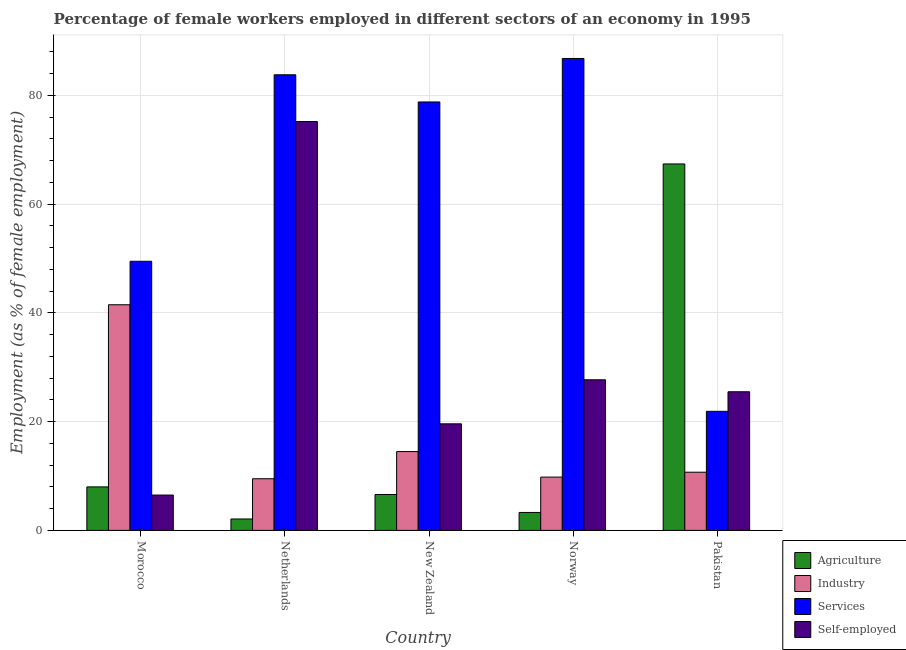How many groups of bars are there?
Offer a very short reply. 5. Are the number of bars per tick equal to the number of legend labels?
Your answer should be compact. Yes. Are the number of bars on each tick of the X-axis equal?
Your answer should be compact. Yes. How many bars are there on the 5th tick from the right?
Ensure brevity in your answer.  4. What is the label of the 2nd group of bars from the left?
Make the answer very short. Netherlands. What is the percentage of female workers in services in Norway?
Your answer should be compact. 86.8. Across all countries, what is the maximum percentage of female workers in services?
Your answer should be compact. 86.8. Across all countries, what is the minimum percentage of self employed female workers?
Give a very brief answer. 6.5. In which country was the percentage of self employed female workers minimum?
Your response must be concise. Morocco. What is the total percentage of female workers in industry in the graph?
Provide a short and direct response. 86. What is the difference between the percentage of female workers in industry in Morocco and that in New Zealand?
Offer a terse response. 27. What is the difference between the percentage of self employed female workers in Netherlands and the percentage of female workers in industry in Pakistan?
Offer a very short reply. 64.5. What is the average percentage of self employed female workers per country?
Your answer should be compact. 30.9. What is the difference between the percentage of female workers in agriculture and percentage of self employed female workers in New Zealand?
Your answer should be very brief. -13. In how many countries, is the percentage of self employed female workers greater than 60 %?
Make the answer very short. 1. What is the ratio of the percentage of female workers in services in Norway to that in Pakistan?
Your response must be concise. 3.96. What is the difference between the highest and the second highest percentage of female workers in services?
Provide a short and direct response. 3. What is the difference between the highest and the lowest percentage of self employed female workers?
Offer a terse response. 68.7. Is it the case that in every country, the sum of the percentage of female workers in services and percentage of self employed female workers is greater than the sum of percentage of female workers in agriculture and percentage of female workers in industry?
Ensure brevity in your answer.  Yes. What does the 2nd bar from the left in New Zealand represents?
Give a very brief answer. Industry. What does the 4th bar from the right in Morocco represents?
Provide a succinct answer. Agriculture. Are all the bars in the graph horizontal?
Provide a short and direct response. No. What is the difference between two consecutive major ticks on the Y-axis?
Your answer should be very brief. 20. Does the graph contain grids?
Make the answer very short. Yes. Where does the legend appear in the graph?
Your answer should be compact. Bottom right. How many legend labels are there?
Provide a succinct answer. 4. What is the title of the graph?
Offer a terse response. Percentage of female workers employed in different sectors of an economy in 1995. What is the label or title of the Y-axis?
Offer a terse response. Employment (as % of female employment). What is the Employment (as % of female employment) in Agriculture in Morocco?
Your answer should be compact. 8. What is the Employment (as % of female employment) of Industry in Morocco?
Provide a short and direct response. 41.5. What is the Employment (as % of female employment) in Services in Morocco?
Your answer should be very brief. 49.5. What is the Employment (as % of female employment) of Agriculture in Netherlands?
Give a very brief answer. 2.1. What is the Employment (as % of female employment) of Industry in Netherlands?
Offer a very short reply. 9.5. What is the Employment (as % of female employment) in Services in Netherlands?
Your answer should be compact. 83.8. What is the Employment (as % of female employment) in Self-employed in Netherlands?
Your response must be concise. 75.2. What is the Employment (as % of female employment) in Agriculture in New Zealand?
Offer a terse response. 6.6. What is the Employment (as % of female employment) of Industry in New Zealand?
Offer a very short reply. 14.5. What is the Employment (as % of female employment) of Services in New Zealand?
Ensure brevity in your answer.  78.8. What is the Employment (as % of female employment) of Self-employed in New Zealand?
Give a very brief answer. 19.6. What is the Employment (as % of female employment) in Agriculture in Norway?
Offer a very short reply. 3.3. What is the Employment (as % of female employment) of Industry in Norway?
Your answer should be very brief. 9.8. What is the Employment (as % of female employment) of Services in Norway?
Your answer should be compact. 86.8. What is the Employment (as % of female employment) in Self-employed in Norway?
Give a very brief answer. 27.7. What is the Employment (as % of female employment) of Agriculture in Pakistan?
Ensure brevity in your answer.  67.4. What is the Employment (as % of female employment) of Industry in Pakistan?
Keep it short and to the point. 10.7. What is the Employment (as % of female employment) in Services in Pakistan?
Keep it short and to the point. 21.9. Across all countries, what is the maximum Employment (as % of female employment) in Agriculture?
Your answer should be very brief. 67.4. Across all countries, what is the maximum Employment (as % of female employment) in Industry?
Your response must be concise. 41.5. Across all countries, what is the maximum Employment (as % of female employment) of Services?
Offer a very short reply. 86.8. Across all countries, what is the maximum Employment (as % of female employment) of Self-employed?
Offer a very short reply. 75.2. Across all countries, what is the minimum Employment (as % of female employment) in Agriculture?
Keep it short and to the point. 2.1. Across all countries, what is the minimum Employment (as % of female employment) in Services?
Your answer should be very brief. 21.9. What is the total Employment (as % of female employment) of Agriculture in the graph?
Make the answer very short. 87.4. What is the total Employment (as % of female employment) in Industry in the graph?
Make the answer very short. 86. What is the total Employment (as % of female employment) in Services in the graph?
Your answer should be compact. 320.8. What is the total Employment (as % of female employment) of Self-employed in the graph?
Give a very brief answer. 154.5. What is the difference between the Employment (as % of female employment) of Industry in Morocco and that in Netherlands?
Keep it short and to the point. 32. What is the difference between the Employment (as % of female employment) in Services in Morocco and that in Netherlands?
Ensure brevity in your answer.  -34.3. What is the difference between the Employment (as % of female employment) in Self-employed in Morocco and that in Netherlands?
Ensure brevity in your answer.  -68.7. What is the difference between the Employment (as % of female employment) of Industry in Morocco and that in New Zealand?
Keep it short and to the point. 27. What is the difference between the Employment (as % of female employment) in Services in Morocco and that in New Zealand?
Provide a succinct answer. -29.3. What is the difference between the Employment (as % of female employment) of Industry in Morocco and that in Norway?
Keep it short and to the point. 31.7. What is the difference between the Employment (as % of female employment) of Services in Morocco and that in Norway?
Provide a succinct answer. -37.3. What is the difference between the Employment (as % of female employment) of Self-employed in Morocco and that in Norway?
Offer a terse response. -21.2. What is the difference between the Employment (as % of female employment) in Agriculture in Morocco and that in Pakistan?
Your response must be concise. -59.4. What is the difference between the Employment (as % of female employment) in Industry in Morocco and that in Pakistan?
Your answer should be compact. 30.8. What is the difference between the Employment (as % of female employment) in Services in Morocco and that in Pakistan?
Ensure brevity in your answer.  27.6. What is the difference between the Employment (as % of female employment) of Agriculture in Netherlands and that in New Zealand?
Provide a succinct answer. -4.5. What is the difference between the Employment (as % of female employment) in Services in Netherlands and that in New Zealand?
Offer a terse response. 5. What is the difference between the Employment (as % of female employment) in Self-employed in Netherlands and that in New Zealand?
Offer a terse response. 55.6. What is the difference between the Employment (as % of female employment) of Agriculture in Netherlands and that in Norway?
Make the answer very short. -1.2. What is the difference between the Employment (as % of female employment) in Self-employed in Netherlands and that in Norway?
Give a very brief answer. 47.5. What is the difference between the Employment (as % of female employment) of Agriculture in Netherlands and that in Pakistan?
Keep it short and to the point. -65.3. What is the difference between the Employment (as % of female employment) of Services in Netherlands and that in Pakistan?
Provide a short and direct response. 61.9. What is the difference between the Employment (as % of female employment) in Self-employed in Netherlands and that in Pakistan?
Offer a very short reply. 49.7. What is the difference between the Employment (as % of female employment) of Agriculture in New Zealand and that in Norway?
Your response must be concise. 3.3. What is the difference between the Employment (as % of female employment) in Industry in New Zealand and that in Norway?
Provide a succinct answer. 4.7. What is the difference between the Employment (as % of female employment) of Services in New Zealand and that in Norway?
Your response must be concise. -8. What is the difference between the Employment (as % of female employment) of Self-employed in New Zealand and that in Norway?
Your answer should be compact. -8.1. What is the difference between the Employment (as % of female employment) in Agriculture in New Zealand and that in Pakistan?
Provide a short and direct response. -60.8. What is the difference between the Employment (as % of female employment) of Services in New Zealand and that in Pakistan?
Keep it short and to the point. 56.9. What is the difference between the Employment (as % of female employment) in Agriculture in Norway and that in Pakistan?
Offer a very short reply. -64.1. What is the difference between the Employment (as % of female employment) in Services in Norway and that in Pakistan?
Give a very brief answer. 64.9. What is the difference between the Employment (as % of female employment) in Self-employed in Norway and that in Pakistan?
Provide a short and direct response. 2.2. What is the difference between the Employment (as % of female employment) in Agriculture in Morocco and the Employment (as % of female employment) in Industry in Netherlands?
Your response must be concise. -1.5. What is the difference between the Employment (as % of female employment) of Agriculture in Morocco and the Employment (as % of female employment) of Services in Netherlands?
Offer a terse response. -75.8. What is the difference between the Employment (as % of female employment) of Agriculture in Morocco and the Employment (as % of female employment) of Self-employed in Netherlands?
Your answer should be very brief. -67.2. What is the difference between the Employment (as % of female employment) of Industry in Morocco and the Employment (as % of female employment) of Services in Netherlands?
Provide a short and direct response. -42.3. What is the difference between the Employment (as % of female employment) in Industry in Morocco and the Employment (as % of female employment) in Self-employed in Netherlands?
Ensure brevity in your answer.  -33.7. What is the difference between the Employment (as % of female employment) of Services in Morocco and the Employment (as % of female employment) of Self-employed in Netherlands?
Your response must be concise. -25.7. What is the difference between the Employment (as % of female employment) of Agriculture in Morocco and the Employment (as % of female employment) of Industry in New Zealand?
Make the answer very short. -6.5. What is the difference between the Employment (as % of female employment) in Agriculture in Morocco and the Employment (as % of female employment) in Services in New Zealand?
Offer a terse response. -70.8. What is the difference between the Employment (as % of female employment) in Industry in Morocco and the Employment (as % of female employment) in Services in New Zealand?
Make the answer very short. -37.3. What is the difference between the Employment (as % of female employment) in Industry in Morocco and the Employment (as % of female employment) in Self-employed in New Zealand?
Your answer should be very brief. 21.9. What is the difference between the Employment (as % of female employment) of Services in Morocco and the Employment (as % of female employment) of Self-employed in New Zealand?
Your answer should be very brief. 29.9. What is the difference between the Employment (as % of female employment) in Agriculture in Morocco and the Employment (as % of female employment) in Industry in Norway?
Offer a very short reply. -1.8. What is the difference between the Employment (as % of female employment) of Agriculture in Morocco and the Employment (as % of female employment) of Services in Norway?
Ensure brevity in your answer.  -78.8. What is the difference between the Employment (as % of female employment) in Agriculture in Morocco and the Employment (as % of female employment) in Self-employed in Norway?
Your response must be concise. -19.7. What is the difference between the Employment (as % of female employment) of Industry in Morocco and the Employment (as % of female employment) of Services in Norway?
Your response must be concise. -45.3. What is the difference between the Employment (as % of female employment) of Services in Morocco and the Employment (as % of female employment) of Self-employed in Norway?
Your answer should be compact. 21.8. What is the difference between the Employment (as % of female employment) of Agriculture in Morocco and the Employment (as % of female employment) of Industry in Pakistan?
Offer a terse response. -2.7. What is the difference between the Employment (as % of female employment) in Agriculture in Morocco and the Employment (as % of female employment) in Services in Pakistan?
Provide a short and direct response. -13.9. What is the difference between the Employment (as % of female employment) in Agriculture in Morocco and the Employment (as % of female employment) in Self-employed in Pakistan?
Your response must be concise. -17.5. What is the difference between the Employment (as % of female employment) in Industry in Morocco and the Employment (as % of female employment) in Services in Pakistan?
Your answer should be very brief. 19.6. What is the difference between the Employment (as % of female employment) in Services in Morocco and the Employment (as % of female employment) in Self-employed in Pakistan?
Provide a short and direct response. 24. What is the difference between the Employment (as % of female employment) of Agriculture in Netherlands and the Employment (as % of female employment) of Industry in New Zealand?
Give a very brief answer. -12.4. What is the difference between the Employment (as % of female employment) in Agriculture in Netherlands and the Employment (as % of female employment) in Services in New Zealand?
Offer a very short reply. -76.7. What is the difference between the Employment (as % of female employment) in Agriculture in Netherlands and the Employment (as % of female employment) in Self-employed in New Zealand?
Your answer should be compact. -17.5. What is the difference between the Employment (as % of female employment) in Industry in Netherlands and the Employment (as % of female employment) in Services in New Zealand?
Give a very brief answer. -69.3. What is the difference between the Employment (as % of female employment) in Services in Netherlands and the Employment (as % of female employment) in Self-employed in New Zealand?
Provide a short and direct response. 64.2. What is the difference between the Employment (as % of female employment) of Agriculture in Netherlands and the Employment (as % of female employment) of Industry in Norway?
Make the answer very short. -7.7. What is the difference between the Employment (as % of female employment) in Agriculture in Netherlands and the Employment (as % of female employment) in Services in Norway?
Give a very brief answer. -84.7. What is the difference between the Employment (as % of female employment) in Agriculture in Netherlands and the Employment (as % of female employment) in Self-employed in Norway?
Make the answer very short. -25.6. What is the difference between the Employment (as % of female employment) in Industry in Netherlands and the Employment (as % of female employment) in Services in Norway?
Ensure brevity in your answer.  -77.3. What is the difference between the Employment (as % of female employment) in Industry in Netherlands and the Employment (as % of female employment) in Self-employed in Norway?
Provide a short and direct response. -18.2. What is the difference between the Employment (as % of female employment) in Services in Netherlands and the Employment (as % of female employment) in Self-employed in Norway?
Provide a succinct answer. 56.1. What is the difference between the Employment (as % of female employment) in Agriculture in Netherlands and the Employment (as % of female employment) in Services in Pakistan?
Keep it short and to the point. -19.8. What is the difference between the Employment (as % of female employment) in Agriculture in Netherlands and the Employment (as % of female employment) in Self-employed in Pakistan?
Give a very brief answer. -23.4. What is the difference between the Employment (as % of female employment) of Industry in Netherlands and the Employment (as % of female employment) of Services in Pakistan?
Your response must be concise. -12.4. What is the difference between the Employment (as % of female employment) in Services in Netherlands and the Employment (as % of female employment) in Self-employed in Pakistan?
Your response must be concise. 58.3. What is the difference between the Employment (as % of female employment) of Agriculture in New Zealand and the Employment (as % of female employment) of Industry in Norway?
Provide a short and direct response. -3.2. What is the difference between the Employment (as % of female employment) in Agriculture in New Zealand and the Employment (as % of female employment) in Services in Norway?
Make the answer very short. -80.2. What is the difference between the Employment (as % of female employment) in Agriculture in New Zealand and the Employment (as % of female employment) in Self-employed in Norway?
Offer a terse response. -21.1. What is the difference between the Employment (as % of female employment) in Industry in New Zealand and the Employment (as % of female employment) in Services in Norway?
Your response must be concise. -72.3. What is the difference between the Employment (as % of female employment) of Services in New Zealand and the Employment (as % of female employment) of Self-employed in Norway?
Offer a very short reply. 51.1. What is the difference between the Employment (as % of female employment) in Agriculture in New Zealand and the Employment (as % of female employment) in Services in Pakistan?
Ensure brevity in your answer.  -15.3. What is the difference between the Employment (as % of female employment) in Agriculture in New Zealand and the Employment (as % of female employment) in Self-employed in Pakistan?
Your answer should be compact. -18.9. What is the difference between the Employment (as % of female employment) of Industry in New Zealand and the Employment (as % of female employment) of Services in Pakistan?
Provide a succinct answer. -7.4. What is the difference between the Employment (as % of female employment) in Services in New Zealand and the Employment (as % of female employment) in Self-employed in Pakistan?
Your answer should be compact. 53.3. What is the difference between the Employment (as % of female employment) in Agriculture in Norway and the Employment (as % of female employment) in Industry in Pakistan?
Make the answer very short. -7.4. What is the difference between the Employment (as % of female employment) of Agriculture in Norway and the Employment (as % of female employment) of Services in Pakistan?
Provide a succinct answer. -18.6. What is the difference between the Employment (as % of female employment) of Agriculture in Norway and the Employment (as % of female employment) of Self-employed in Pakistan?
Offer a very short reply. -22.2. What is the difference between the Employment (as % of female employment) of Industry in Norway and the Employment (as % of female employment) of Services in Pakistan?
Ensure brevity in your answer.  -12.1. What is the difference between the Employment (as % of female employment) of Industry in Norway and the Employment (as % of female employment) of Self-employed in Pakistan?
Make the answer very short. -15.7. What is the difference between the Employment (as % of female employment) in Services in Norway and the Employment (as % of female employment) in Self-employed in Pakistan?
Offer a terse response. 61.3. What is the average Employment (as % of female employment) in Agriculture per country?
Your response must be concise. 17.48. What is the average Employment (as % of female employment) in Industry per country?
Your response must be concise. 17.2. What is the average Employment (as % of female employment) in Services per country?
Give a very brief answer. 64.16. What is the average Employment (as % of female employment) of Self-employed per country?
Provide a succinct answer. 30.9. What is the difference between the Employment (as % of female employment) of Agriculture and Employment (as % of female employment) of Industry in Morocco?
Offer a very short reply. -33.5. What is the difference between the Employment (as % of female employment) of Agriculture and Employment (as % of female employment) of Services in Morocco?
Provide a succinct answer. -41.5. What is the difference between the Employment (as % of female employment) of Industry and Employment (as % of female employment) of Services in Morocco?
Your answer should be very brief. -8. What is the difference between the Employment (as % of female employment) of Industry and Employment (as % of female employment) of Self-employed in Morocco?
Offer a very short reply. 35. What is the difference between the Employment (as % of female employment) of Agriculture and Employment (as % of female employment) of Services in Netherlands?
Your response must be concise. -81.7. What is the difference between the Employment (as % of female employment) in Agriculture and Employment (as % of female employment) in Self-employed in Netherlands?
Give a very brief answer. -73.1. What is the difference between the Employment (as % of female employment) in Industry and Employment (as % of female employment) in Services in Netherlands?
Provide a succinct answer. -74.3. What is the difference between the Employment (as % of female employment) of Industry and Employment (as % of female employment) of Self-employed in Netherlands?
Your answer should be very brief. -65.7. What is the difference between the Employment (as % of female employment) of Services and Employment (as % of female employment) of Self-employed in Netherlands?
Offer a very short reply. 8.6. What is the difference between the Employment (as % of female employment) of Agriculture and Employment (as % of female employment) of Services in New Zealand?
Keep it short and to the point. -72.2. What is the difference between the Employment (as % of female employment) in Agriculture and Employment (as % of female employment) in Self-employed in New Zealand?
Keep it short and to the point. -13. What is the difference between the Employment (as % of female employment) of Industry and Employment (as % of female employment) of Services in New Zealand?
Make the answer very short. -64.3. What is the difference between the Employment (as % of female employment) in Industry and Employment (as % of female employment) in Self-employed in New Zealand?
Make the answer very short. -5.1. What is the difference between the Employment (as % of female employment) in Services and Employment (as % of female employment) in Self-employed in New Zealand?
Give a very brief answer. 59.2. What is the difference between the Employment (as % of female employment) of Agriculture and Employment (as % of female employment) of Services in Norway?
Provide a short and direct response. -83.5. What is the difference between the Employment (as % of female employment) in Agriculture and Employment (as % of female employment) in Self-employed in Norway?
Give a very brief answer. -24.4. What is the difference between the Employment (as % of female employment) in Industry and Employment (as % of female employment) in Services in Norway?
Your answer should be very brief. -77. What is the difference between the Employment (as % of female employment) of Industry and Employment (as % of female employment) of Self-employed in Norway?
Offer a terse response. -17.9. What is the difference between the Employment (as % of female employment) in Services and Employment (as % of female employment) in Self-employed in Norway?
Make the answer very short. 59.1. What is the difference between the Employment (as % of female employment) of Agriculture and Employment (as % of female employment) of Industry in Pakistan?
Offer a terse response. 56.7. What is the difference between the Employment (as % of female employment) of Agriculture and Employment (as % of female employment) of Services in Pakistan?
Offer a very short reply. 45.5. What is the difference between the Employment (as % of female employment) in Agriculture and Employment (as % of female employment) in Self-employed in Pakistan?
Provide a succinct answer. 41.9. What is the difference between the Employment (as % of female employment) in Industry and Employment (as % of female employment) in Services in Pakistan?
Your answer should be very brief. -11.2. What is the difference between the Employment (as % of female employment) in Industry and Employment (as % of female employment) in Self-employed in Pakistan?
Offer a very short reply. -14.8. What is the ratio of the Employment (as % of female employment) of Agriculture in Morocco to that in Netherlands?
Your answer should be compact. 3.81. What is the ratio of the Employment (as % of female employment) in Industry in Morocco to that in Netherlands?
Keep it short and to the point. 4.37. What is the ratio of the Employment (as % of female employment) in Services in Morocco to that in Netherlands?
Your answer should be very brief. 0.59. What is the ratio of the Employment (as % of female employment) of Self-employed in Morocco to that in Netherlands?
Provide a short and direct response. 0.09. What is the ratio of the Employment (as % of female employment) of Agriculture in Morocco to that in New Zealand?
Ensure brevity in your answer.  1.21. What is the ratio of the Employment (as % of female employment) in Industry in Morocco to that in New Zealand?
Ensure brevity in your answer.  2.86. What is the ratio of the Employment (as % of female employment) of Services in Morocco to that in New Zealand?
Give a very brief answer. 0.63. What is the ratio of the Employment (as % of female employment) of Self-employed in Morocco to that in New Zealand?
Your answer should be compact. 0.33. What is the ratio of the Employment (as % of female employment) of Agriculture in Morocco to that in Norway?
Offer a very short reply. 2.42. What is the ratio of the Employment (as % of female employment) of Industry in Morocco to that in Norway?
Make the answer very short. 4.23. What is the ratio of the Employment (as % of female employment) in Services in Morocco to that in Norway?
Provide a succinct answer. 0.57. What is the ratio of the Employment (as % of female employment) of Self-employed in Morocco to that in Norway?
Provide a short and direct response. 0.23. What is the ratio of the Employment (as % of female employment) of Agriculture in Morocco to that in Pakistan?
Keep it short and to the point. 0.12. What is the ratio of the Employment (as % of female employment) of Industry in Morocco to that in Pakistan?
Offer a terse response. 3.88. What is the ratio of the Employment (as % of female employment) in Services in Morocco to that in Pakistan?
Give a very brief answer. 2.26. What is the ratio of the Employment (as % of female employment) of Self-employed in Morocco to that in Pakistan?
Your response must be concise. 0.25. What is the ratio of the Employment (as % of female employment) of Agriculture in Netherlands to that in New Zealand?
Your response must be concise. 0.32. What is the ratio of the Employment (as % of female employment) of Industry in Netherlands to that in New Zealand?
Offer a very short reply. 0.66. What is the ratio of the Employment (as % of female employment) in Services in Netherlands to that in New Zealand?
Provide a succinct answer. 1.06. What is the ratio of the Employment (as % of female employment) in Self-employed in Netherlands to that in New Zealand?
Provide a short and direct response. 3.84. What is the ratio of the Employment (as % of female employment) of Agriculture in Netherlands to that in Norway?
Provide a short and direct response. 0.64. What is the ratio of the Employment (as % of female employment) in Industry in Netherlands to that in Norway?
Keep it short and to the point. 0.97. What is the ratio of the Employment (as % of female employment) of Services in Netherlands to that in Norway?
Offer a terse response. 0.97. What is the ratio of the Employment (as % of female employment) of Self-employed in Netherlands to that in Norway?
Your response must be concise. 2.71. What is the ratio of the Employment (as % of female employment) of Agriculture in Netherlands to that in Pakistan?
Keep it short and to the point. 0.03. What is the ratio of the Employment (as % of female employment) in Industry in Netherlands to that in Pakistan?
Provide a succinct answer. 0.89. What is the ratio of the Employment (as % of female employment) of Services in Netherlands to that in Pakistan?
Offer a very short reply. 3.83. What is the ratio of the Employment (as % of female employment) of Self-employed in Netherlands to that in Pakistan?
Provide a succinct answer. 2.95. What is the ratio of the Employment (as % of female employment) of Industry in New Zealand to that in Norway?
Provide a succinct answer. 1.48. What is the ratio of the Employment (as % of female employment) of Services in New Zealand to that in Norway?
Offer a terse response. 0.91. What is the ratio of the Employment (as % of female employment) in Self-employed in New Zealand to that in Norway?
Keep it short and to the point. 0.71. What is the ratio of the Employment (as % of female employment) in Agriculture in New Zealand to that in Pakistan?
Offer a very short reply. 0.1. What is the ratio of the Employment (as % of female employment) in Industry in New Zealand to that in Pakistan?
Provide a short and direct response. 1.36. What is the ratio of the Employment (as % of female employment) in Services in New Zealand to that in Pakistan?
Provide a short and direct response. 3.6. What is the ratio of the Employment (as % of female employment) of Self-employed in New Zealand to that in Pakistan?
Give a very brief answer. 0.77. What is the ratio of the Employment (as % of female employment) of Agriculture in Norway to that in Pakistan?
Your answer should be very brief. 0.05. What is the ratio of the Employment (as % of female employment) of Industry in Norway to that in Pakistan?
Provide a short and direct response. 0.92. What is the ratio of the Employment (as % of female employment) in Services in Norway to that in Pakistan?
Ensure brevity in your answer.  3.96. What is the ratio of the Employment (as % of female employment) in Self-employed in Norway to that in Pakistan?
Keep it short and to the point. 1.09. What is the difference between the highest and the second highest Employment (as % of female employment) of Agriculture?
Give a very brief answer. 59.4. What is the difference between the highest and the second highest Employment (as % of female employment) of Services?
Offer a terse response. 3. What is the difference between the highest and the second highest Employment (as % of female employment) of Self-employed?
Keep it short and to the point. 47.5. What is the difference between the highest and the lowest Employment (as % of female employment) of Agriculture?
Offer a terse response. 65.3. What is the difference between the highest and the lowest Employment (as % of female employment) in Services?
Your answer should be compact. 64.9. What is the difference between the highest and the lowest Employment (as % of female employment) of Self-employed?
Offer a terse response. 68.7. 